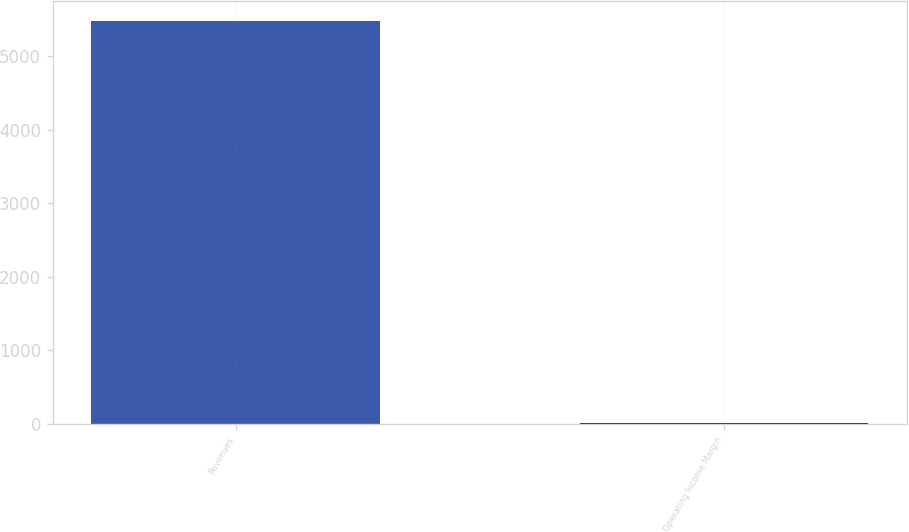Convert chart. <chart><loc_0><loc_0><loc_500><loc_500><bar_chart><fcel>Revenues<fcel>Operating Income Margin<nl><fcel>5473<fcel>14.3<nl></chart> 